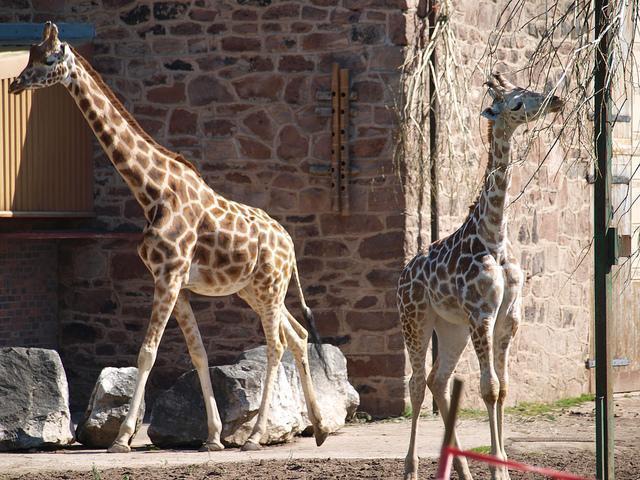How many giraffes can be seen?
Give a very brief answer. 2. How many cars are there?
Give a very brief answer. 0. 